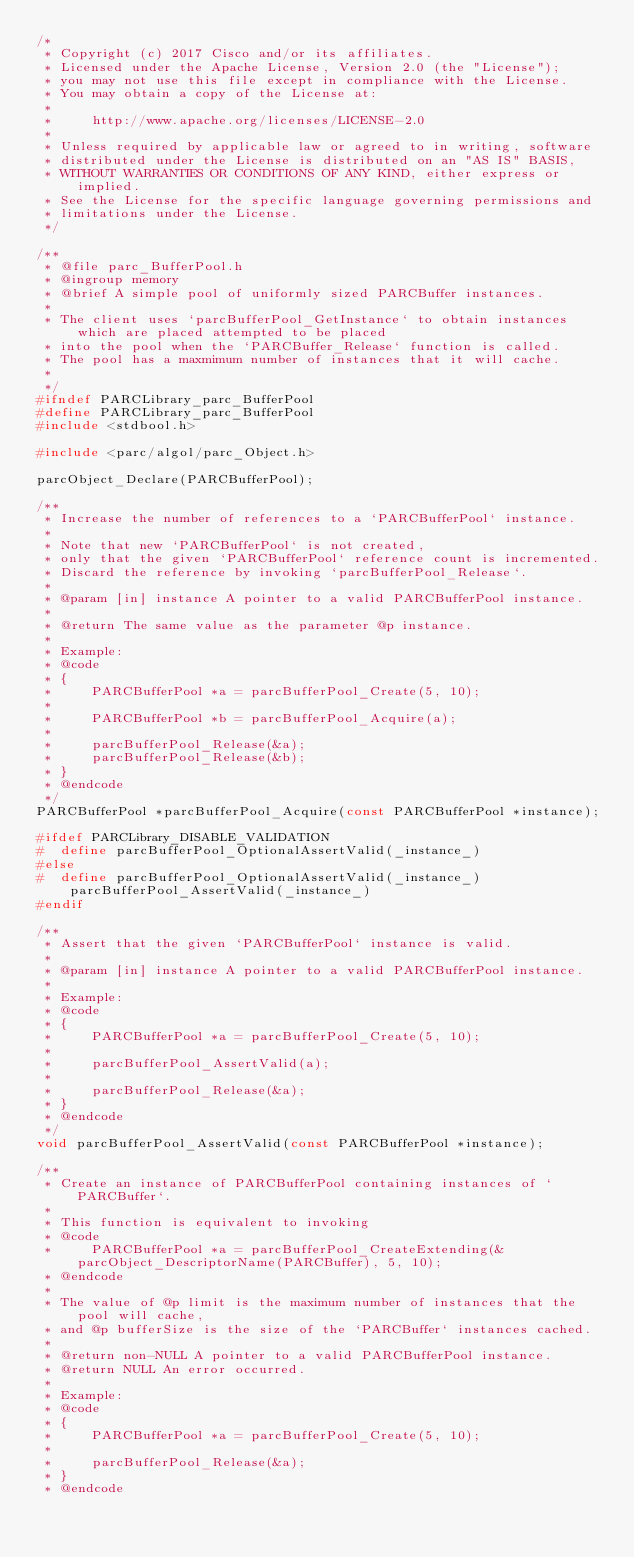<code> <loc_0><loc_0><loc_500><loc_500><_C_>/*
 * Copyright (c) 2017 Cisco and/or its affiliates.
 * Licensed under the Apache License, Version 2.0 (the "License");
 * you may not use this file except in compliance with the License.
 * You may obtain a copy of the License at:
 *
 *     http://www.apache.org/licenses/LICENSE-2.0
 *
 * Unless required by applicable law or agreed to in writing, software
 * distributed under the License is distributed on an "AS IS" BASIS,
 * WITHOUT WARRANTIES OR CONDITIONS OF ANY KIND, either express or implied.
 * See the License for the specific language governing permissions and
 * limitations under the License.
 */

/**
 * @file parc_BufferPool.h
 * @ingroup memory
 * @brief A simple pool of uniformly sized PARCBuffer instances.
 *
 * The client uses `parcBufferPool_GetInstance` to obtain instances which are placed attempted to be placed
 * into the pool when the `PARCBuffer_Release` function is called.
 * The pool has a maxmimum number of instances that it will cache.
 *
 */
#ifndef PARCLibrary_parc_BufferPool
#define PARCLibrary_parc_BufferPool
#include <stdbool.h>

#include <parc/algol/parc_Object.h>

parcObject_Declare(PARCBufferPool);

/**
 * Increase the number of references to a `PARCBufferPool` instance.
 *
 * Note that new `PARCBufferPool` is not created,
 * only that the given `PARCBufferPool` reference count is incremented.
 * Discard the reference by invoking `parcBufferPool_Release`.
 *
 * @param [in] instance A pointer to a valid PARCBufferPool instance.
 *
 * @return The same value as the parameter @p instance.
 *
 * Example:
 * @code
 * {
 *     PARCBufferPool *a = parcBufferPool_Create(5, 10);
 *
 *     PARCBufferPool *b = parcBufferPool_Acquire(a);
 *
 *     parcBufferPool_Release(&a);
 *     parcBufferPool_Release(&b);
 * }
 * @endcode
 */
PARCBufferPool *parcBufferPool_Acquire(const PARCBufferPool *instance);

#ifdef PARCLibrary_DISABLE_VALIDATION
#  define parcBufferPool_OptionalAssertValid(_instance_)
#else
#  define parcBufferPool_OptionalAssertValid(_instance_) parcBufferPool_AssertValid(_instance_)
#endif

/**
 * Assert that the given `PARCBufferPool` instance is valid.
 *
 * @param [in] instance A pointer to a valid PARCBufferPool instance.
 *
 * Example:
 * @code
 * {
 *     PARCBufferPool *a = parcBufferPool_Create(5, 10);
 *
 *     parcBufferPool_AssertValid(a);
 *
 *     parcBufferPool_Release(&a);
 * }
 * @endcode
 */
void parcBufferPool_AssertValid(const PARCBufferPool *instance);

/**
 * Create an instance of PARCBufferPool containing instances of `PARCBuffer`.
 *
 * This function is equivalent to invoking
 * @code
 *     PARCBufferPool *a = parcBufferPool_CreateExtending(&parcObject_DescriptorName(PARCBuffer), 5, 10);
 * @endcode
 *
 * The value of @p limit is the maximum number of instances that the pool will cache,
 * and @p bufferSize is the size of the `PARCBuffer` instances cached.
 *
 * @return non-NULL A pointer to a valid PARCBufferPool instance.
 * @return NULL An error occurred.
 *
 * Example:
 * @code
 * {
 *     PARCBufferPool *a = parcBufferPool_Create(5, 10);
 *
 *     parcBufferPool_Release(&a);
 * }
 * @endcode</code> 